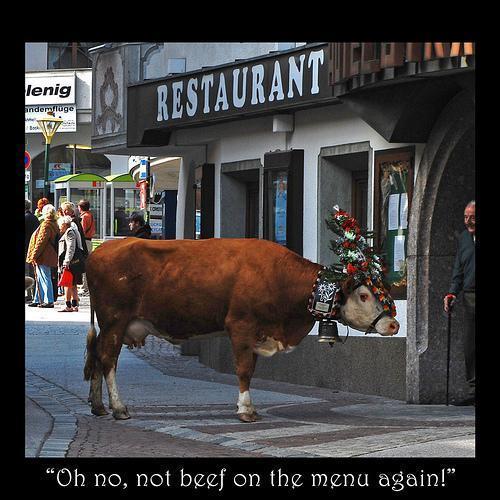How many people can you see?
Give a very brief answer. 2. 